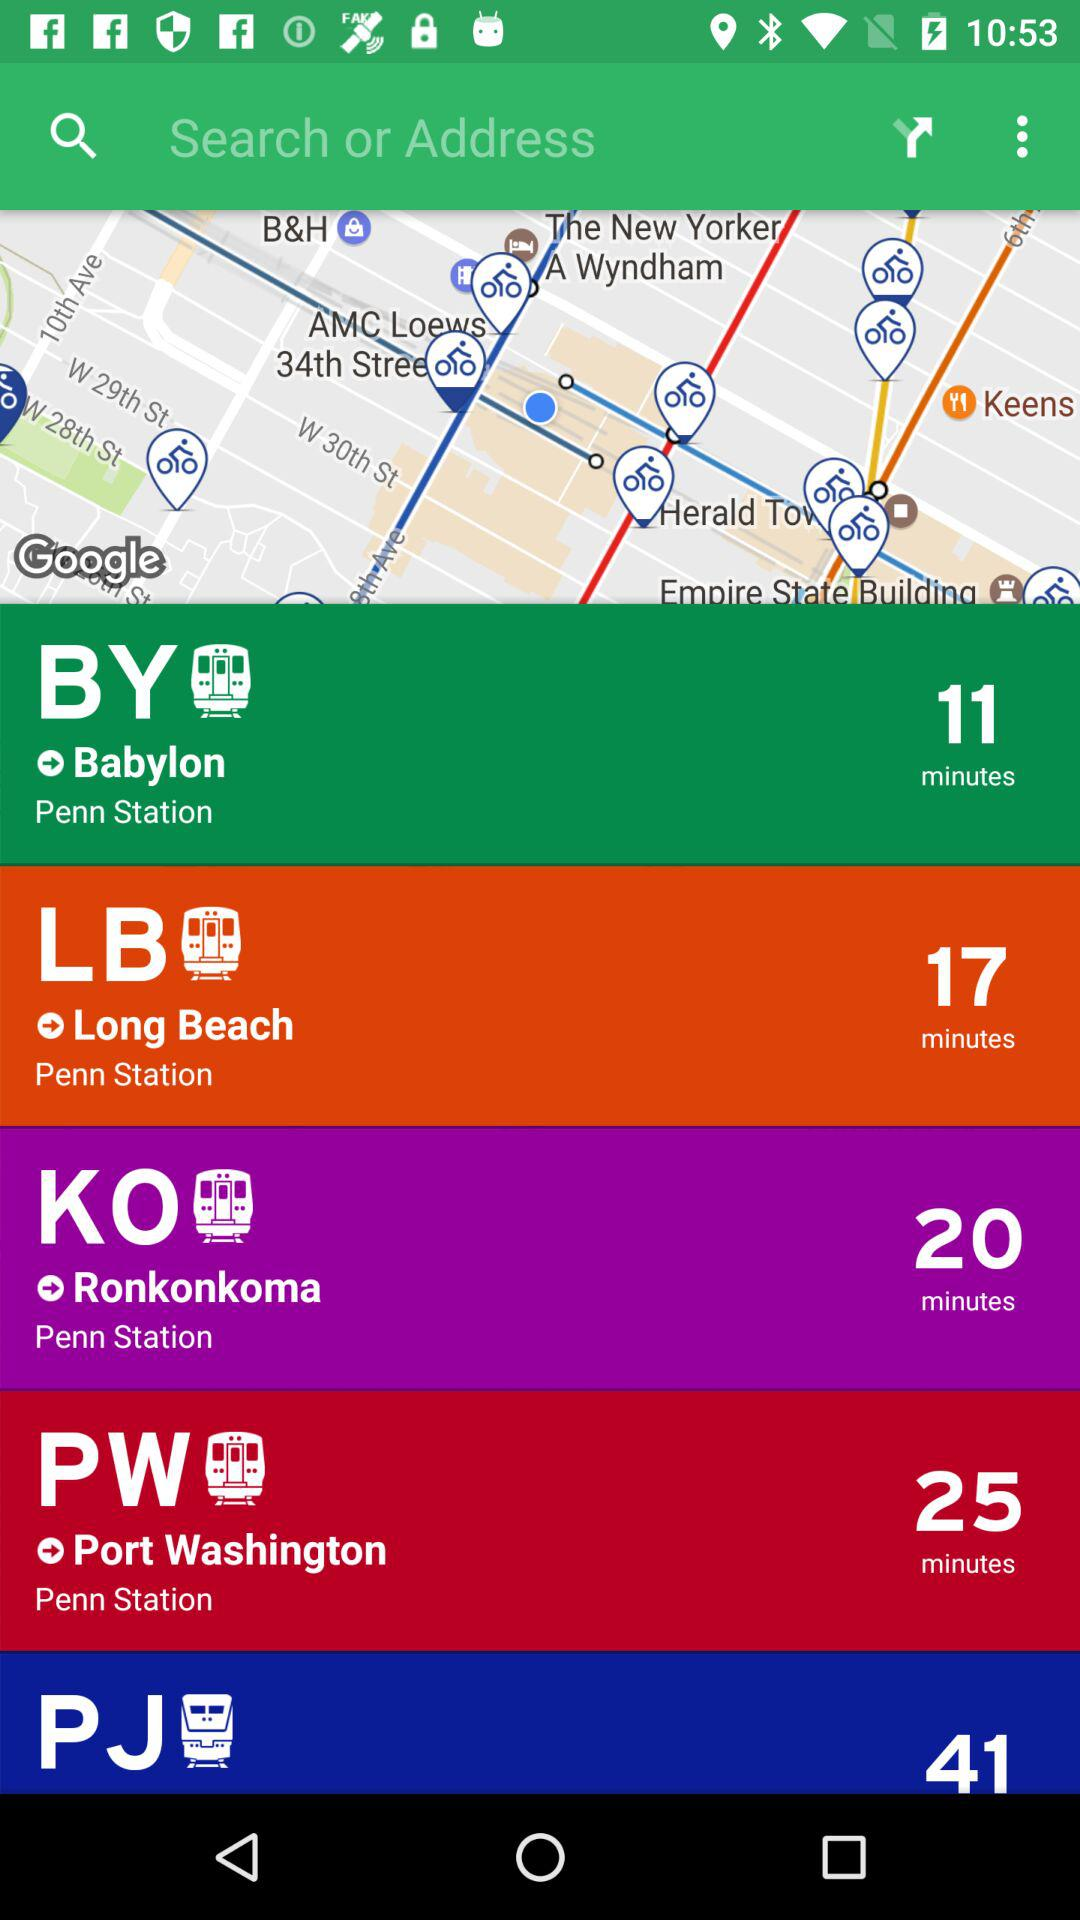Which station has the station code "KO"? The station that has the station code "KO" is "Ronkonkoma". 